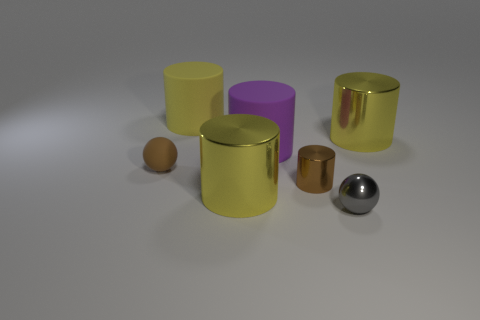What is the material of the other ball that is the same size as the gray ball?
Keep it short and to the point. Rubber. Does the yellow thing in front of the small brown ball have the same size as the sphere that is behind the gray metallic thing?
Your response must be concise. No. What color is the other matte object that is the same shape as the purple matte thing?
Your answer should be very brief. Yellow. Does the purple thing have the same shape as the brown metal object?
Provide a short and direct response. Yes. The other rubber thing that is the same shape as the yellow matte thing is what size?
Give a very brief answer. Large. How many big things have the same material as the small brown cylinder?
Offer a terse response. 2. How many things are balls or large purple metallic things?
Ensure brevity in your answer.  2. Is there a small brown sphere that is in front of the large yellow shiny thing on the left side of the big purple cylinder?
Provide a succinct answer. No. Are there more small shiny cylinders in front of the tiny brown ball than matte cylinders on the right side of the small brown cylinder?
Keep it short and to the point. Yes. What material is the other object that is the same color as the small matte thing?
Provide a short and direct response. Metal. 